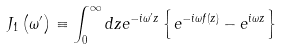<formula> <loc_0><loc_0><loc_500><loc_500>J _ { 1 } \left ( \omega ^ { \prime } \right ) \equiv \int _ { 0 } ^ { \infty } d z e ^ { - i \omega ^ { \prime } z } \left \{ e ^ { - i \omega f ( z ) } - e ^ { i \omega z } \right \}</formula> 